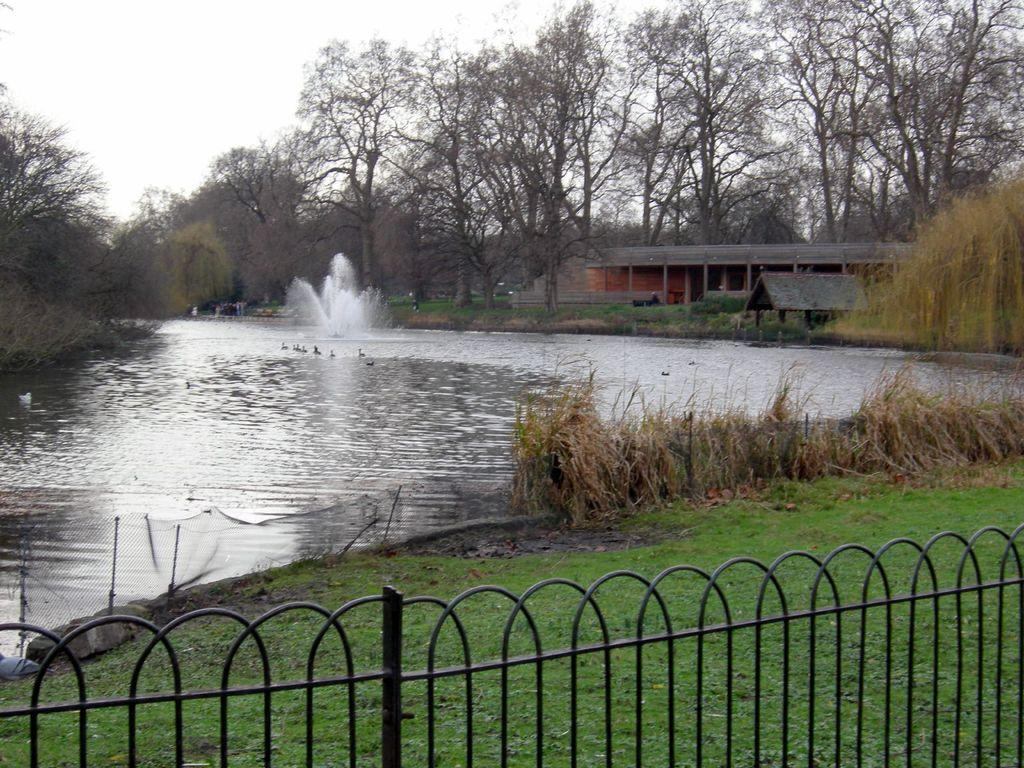What type of terrain is visible at the bottom of the image? There is grass and a fence at the bottom of the image. What can be seen in the background of the image? There is a small pond, houses, and trees in the background of the image. What is visible at the top of the image? The sky is visible at the top of the image. What type of room is depicted on the canvas in the image? There is no canvas or room present in the image. What act are the people performing in the image? There are no people or acts depicted in the image. 